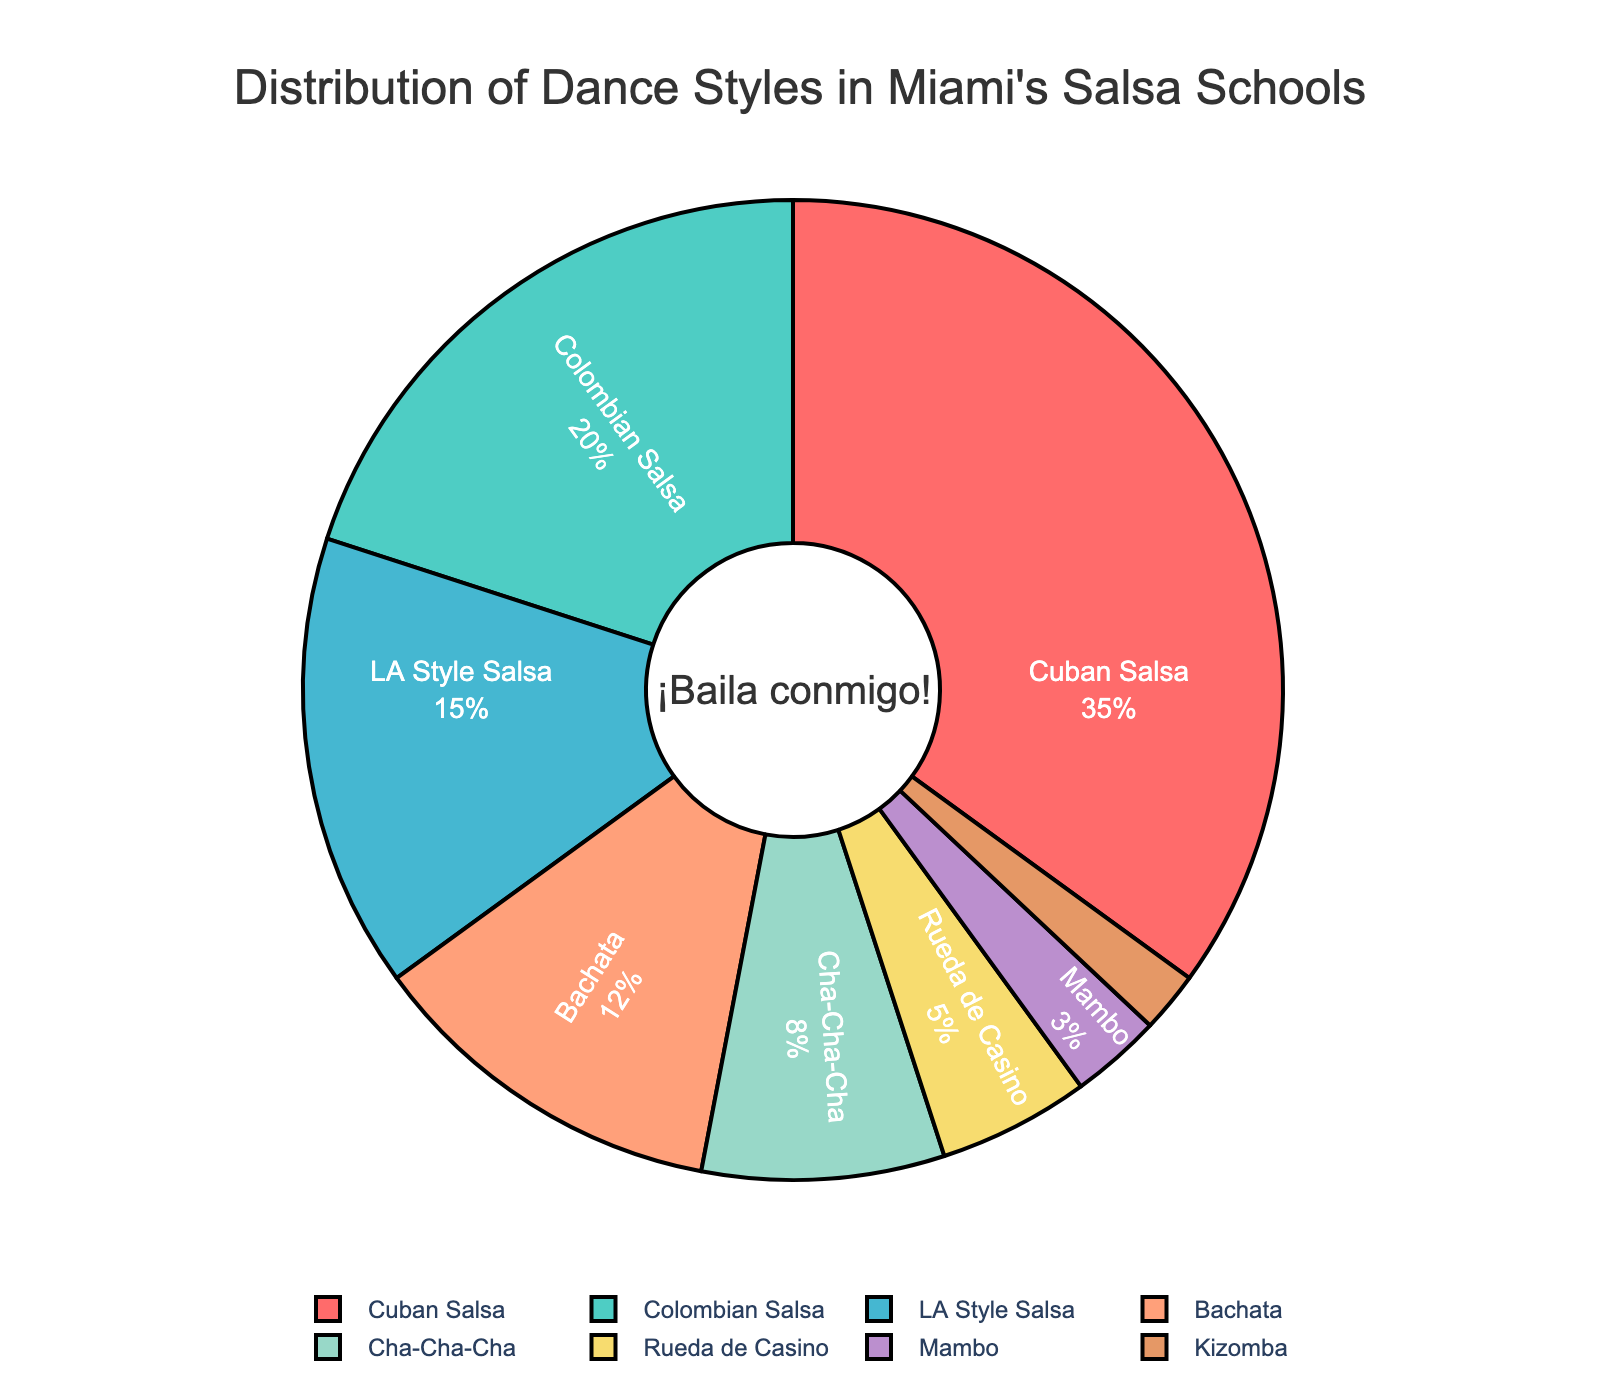What percentage of Miami's salsa dance schools teach Cuban Salsa? Cuban Salsa comprises 35% of the dance styles shown in the pie chart. This percentage is displayed on the chart.
Answer: 35% Which dance style has the smallest representation in the pie chart? Kizomba is the smallest segment shown on the pie chart, with a representation of 2%.
Answer: Kizomba What is the combined percentage of schools that teach Bachata and Cha-Cha-Cha? Adding the percentages for Bachata (12%) and Cha-Cha-Cha (8%) gives 12% + 8% = 20%.
Answer: 20% How does the representation of LA Style Salsa compare to Colombian Salsa? LA Style Salsa represents 15% whereas Colombian Salsa represents 20%. Therefore, Colombian Salsa has a higher percentage than LA Style Salsa.
Answer: Colombian Salsa is higher What is the difference in representation between Cuban Salsa and the next most popular style? The next most popular style is Colombian Salsa at 20%. The difference between Cuban Salsa (35%) and Colombian Salsa is 35% - 20% = 15%.
Answer: 15% What is the total percentage of dance styles other than Cuban Salsa? Adding the percentages of all styles except Cuban Salsa: 20% (Colombian Salsa) + 15% (LA Style Salsa) + 12% (Bachata) + 8% (Cha-Cha-Cha) + 5% (Rueda de Casino) + 3% (Mambo) + 2% (Kizomba) = 65%.
Answer: 65% Which dance styles together account for more than half of the total percentage? Adding Cuban Salsa (35%), Colombian Salsa (20%), and LA Style Salsa (15%) results in 35% + 20% + 15% = 70%, which is more than half of the total.
Answer: Cuban Salsa, Colombian Salsa, LA Style Salsa By what ratio does Bachata exceed Kizomba in terms of representation? Bachata has a representation of 12% and Kizomba has 2%. The ratio is 12% ÷ 2% = 6.
Answer: 6:1 Which dance styles are represented by more than 10% of salsa dance schools? The dance styles with more than 10% representation are Cuban Salsa (35%), Colombian Salsa (20%), and Bachata (12%).
Answer: Cuban Salsa, Colombian Salsa, Bachata What percentage do Rueda de Casino and Mambo together represent? Adding the percentages for Rueda de Casino (5%) and Mambo (3%) gives 5% + 3% = 8%.
Answer: 8% 